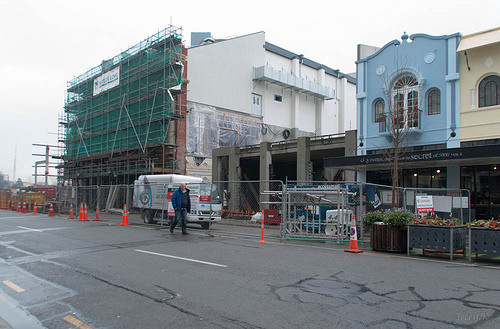<image>
Is there a van on the man? No. The van is not positioned on the man. They may be near each other, but the van is not supported by or resting on top of the man. 